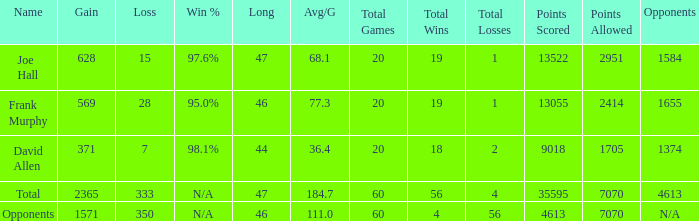Which Avg/G has a Name of david allen, and a Gain larger than 371? None. 